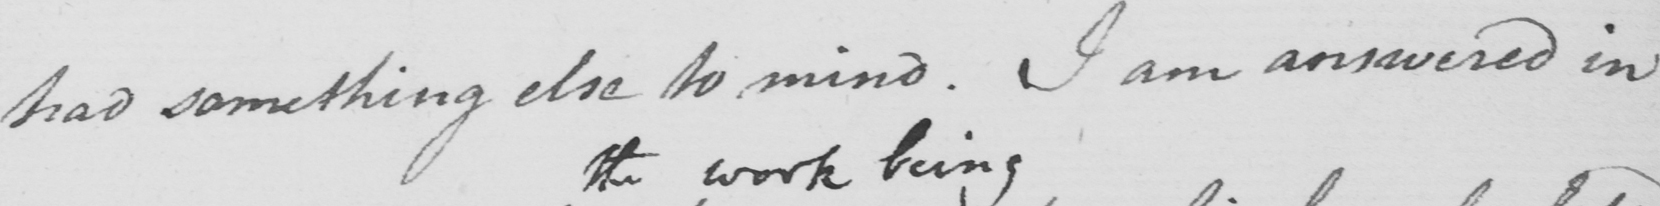Can you read and transcribe this handwriting? had something else to mind . I am answered in 